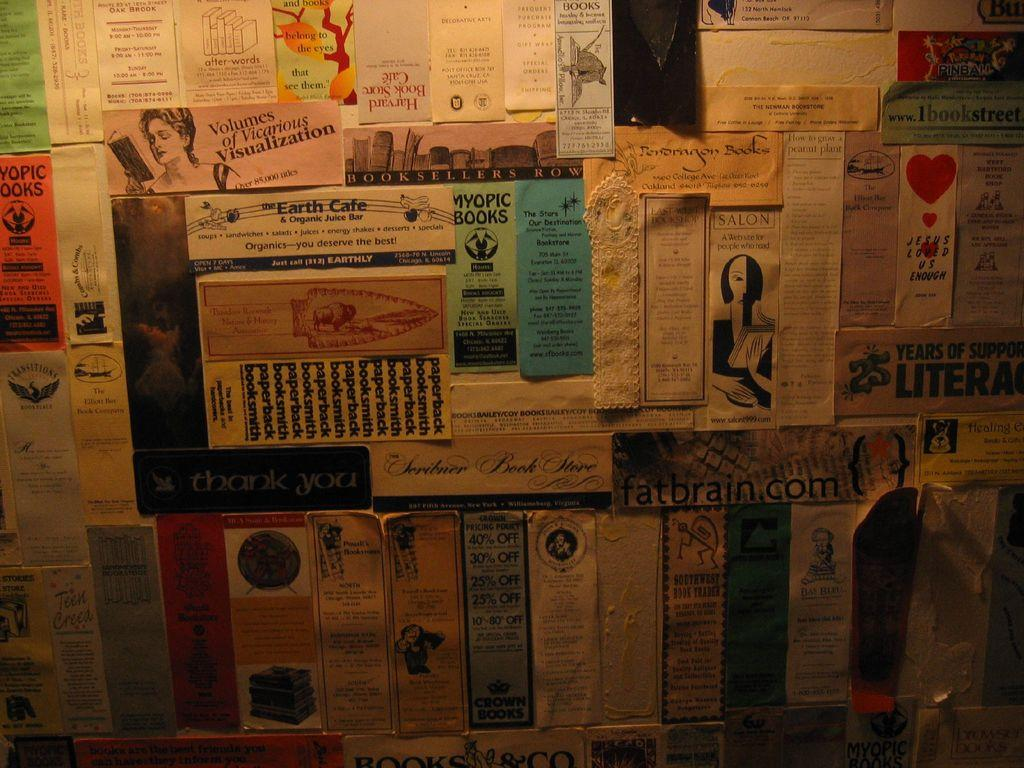<image>
Relay a brief, clear account of the picture shown. Strips of paper in various colors are on a wall promoting different products and companies, incluidng Myopic Books and a salon. 